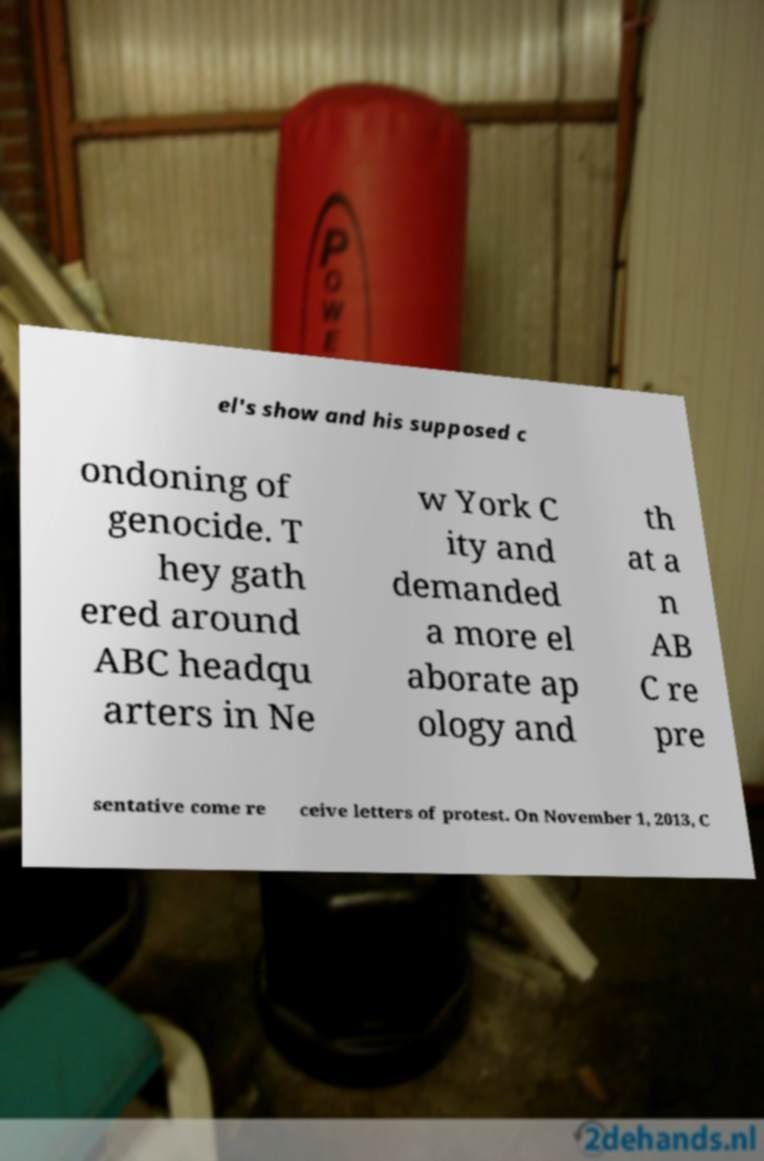What messages or text are displayed in this image? I need them in a readable, typed format. el's show and his supposed c ondoning of genocide. T hey gath ered around ABC headqu arters in Ne w York C ity and demanded a more el aborate ap ology and th at a n AB C re pre sentative come re ceive letters of protest. On November 1, 2013, C 